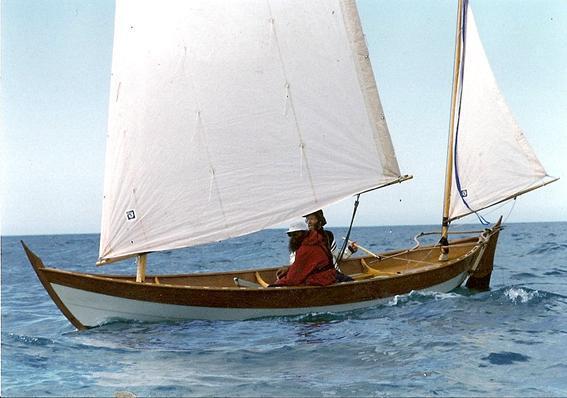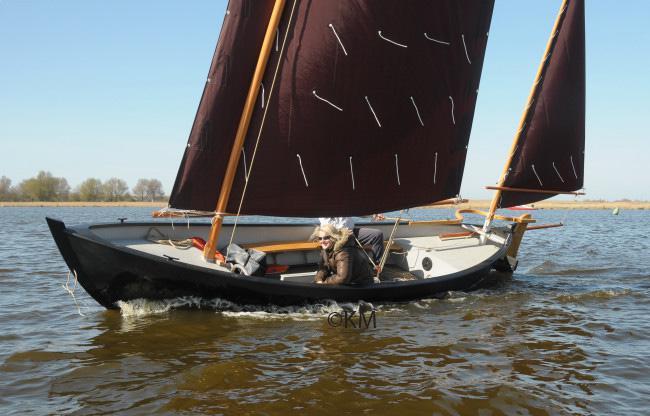The first image is the image on the left, the second image is the image on the right. Evaluate the accuracy of this statement regarding the images: "In at least one image, the trees in the background are merely a short walk away.". Is it true? Answer yes or no. No. The first image is the image on the left, the second image is the image on the right. For the images shown, is this caption "the sails in the image on the right do not have the color white on them." true? Answer yes or no. Yes. 